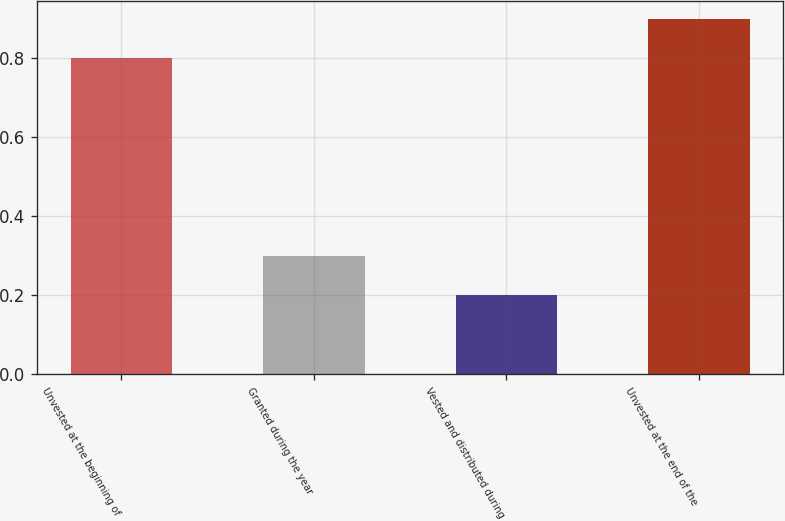Convert chart. <chart><loc_0><loc_0><loc_500><loc_500><bar_chart><fcel>Unvested at the beginning of<fcel>Granted during the year<fcel>Vested and distributed during<fcel>Unvested at the end of the<nl><fcel>0.8<fcel>0.3<fcel>0.2<fcel>0.9<nl></chart> 